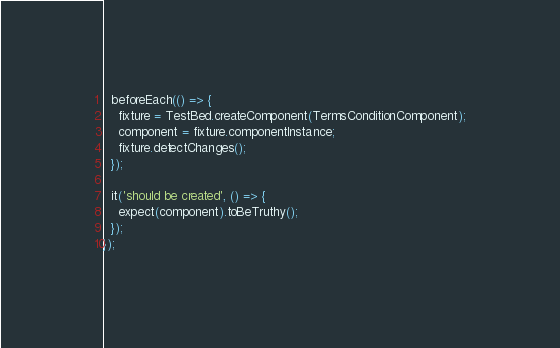<code> <loc_0><loc_0><loc_500><loc_500><_TypeScript_>
  beforeEach(() => {
    fixture = TestBed.createComponent(TermsConditionComponent);
    component = fixture.componentInstance;
    fixture.detectChanges();
  });

  it('should be created', () => {
    expect(component).toBeTruthy();
  });
});
</code> 